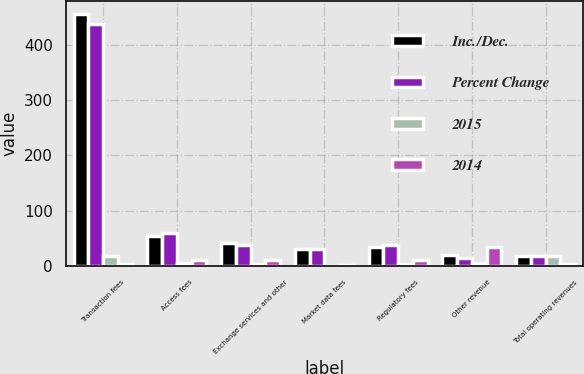<chart> <loc_0><loc_0><loc_500><loc_500><stacked_bar_chart><ecel><fcel>Transaction fees<fcel>Access fees<fcel>Exchange services and other<fcel>Market data fees<fcel>Regulatory fees<fcel>Other revenue<fcel>Total operating revenues<nl><fcel>Inc./Dec.<fcel>456<fcel>53.3<fcel>42.2<fcel>30<fcel>33.5<fcel>19.5<fcel>17.75<nl><fcel>Percent Change<fcel>437.8<fcel>59.3<fcel>38<fcel>30.4<fcel>37.1<fcel>14.6<fcel>17.75<nl><fcel>2015<fcel>18.2<fcel>6<fcel>4.2<fcel>0.4<fcel>3.6<fcel>4.9<fcel>17.3<nl><fcel>2014<fcel>4.2<fcel>10.2<fcel>11<fcel>1.4<fcel>9.7<fcel>34<fcel>2.8<nl></chart> 